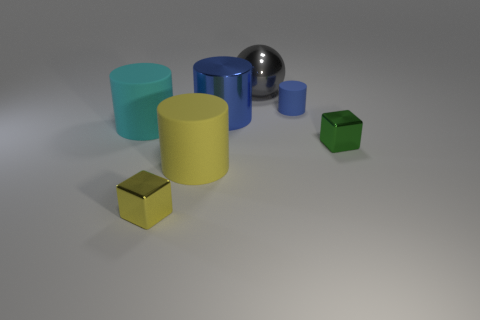Subtract all small blue cylinders. How many cylinders are left? 3 Subtract all cubes. How many objects are left? 5 Subtract all blue cylinders. How many cylinders are left? 2 Add 2 yellow things. How many yellow things exist? 4 Add 2 cylinders. How many objects exist? 9 Subtract 0 purple cylinders. How many objects are left? 7 Subtract 2 cylinders. How many cylinders are left? 2 Subtract all brown cylinders. Subtract all yellow blocks. How many cylinders are left? 4 Subtract all red cylinders. How many green cubes are left? 1 Subtract all tiny blue shiny cylinders. Subtract all big yellow cylinders. How many objects are left? 6 